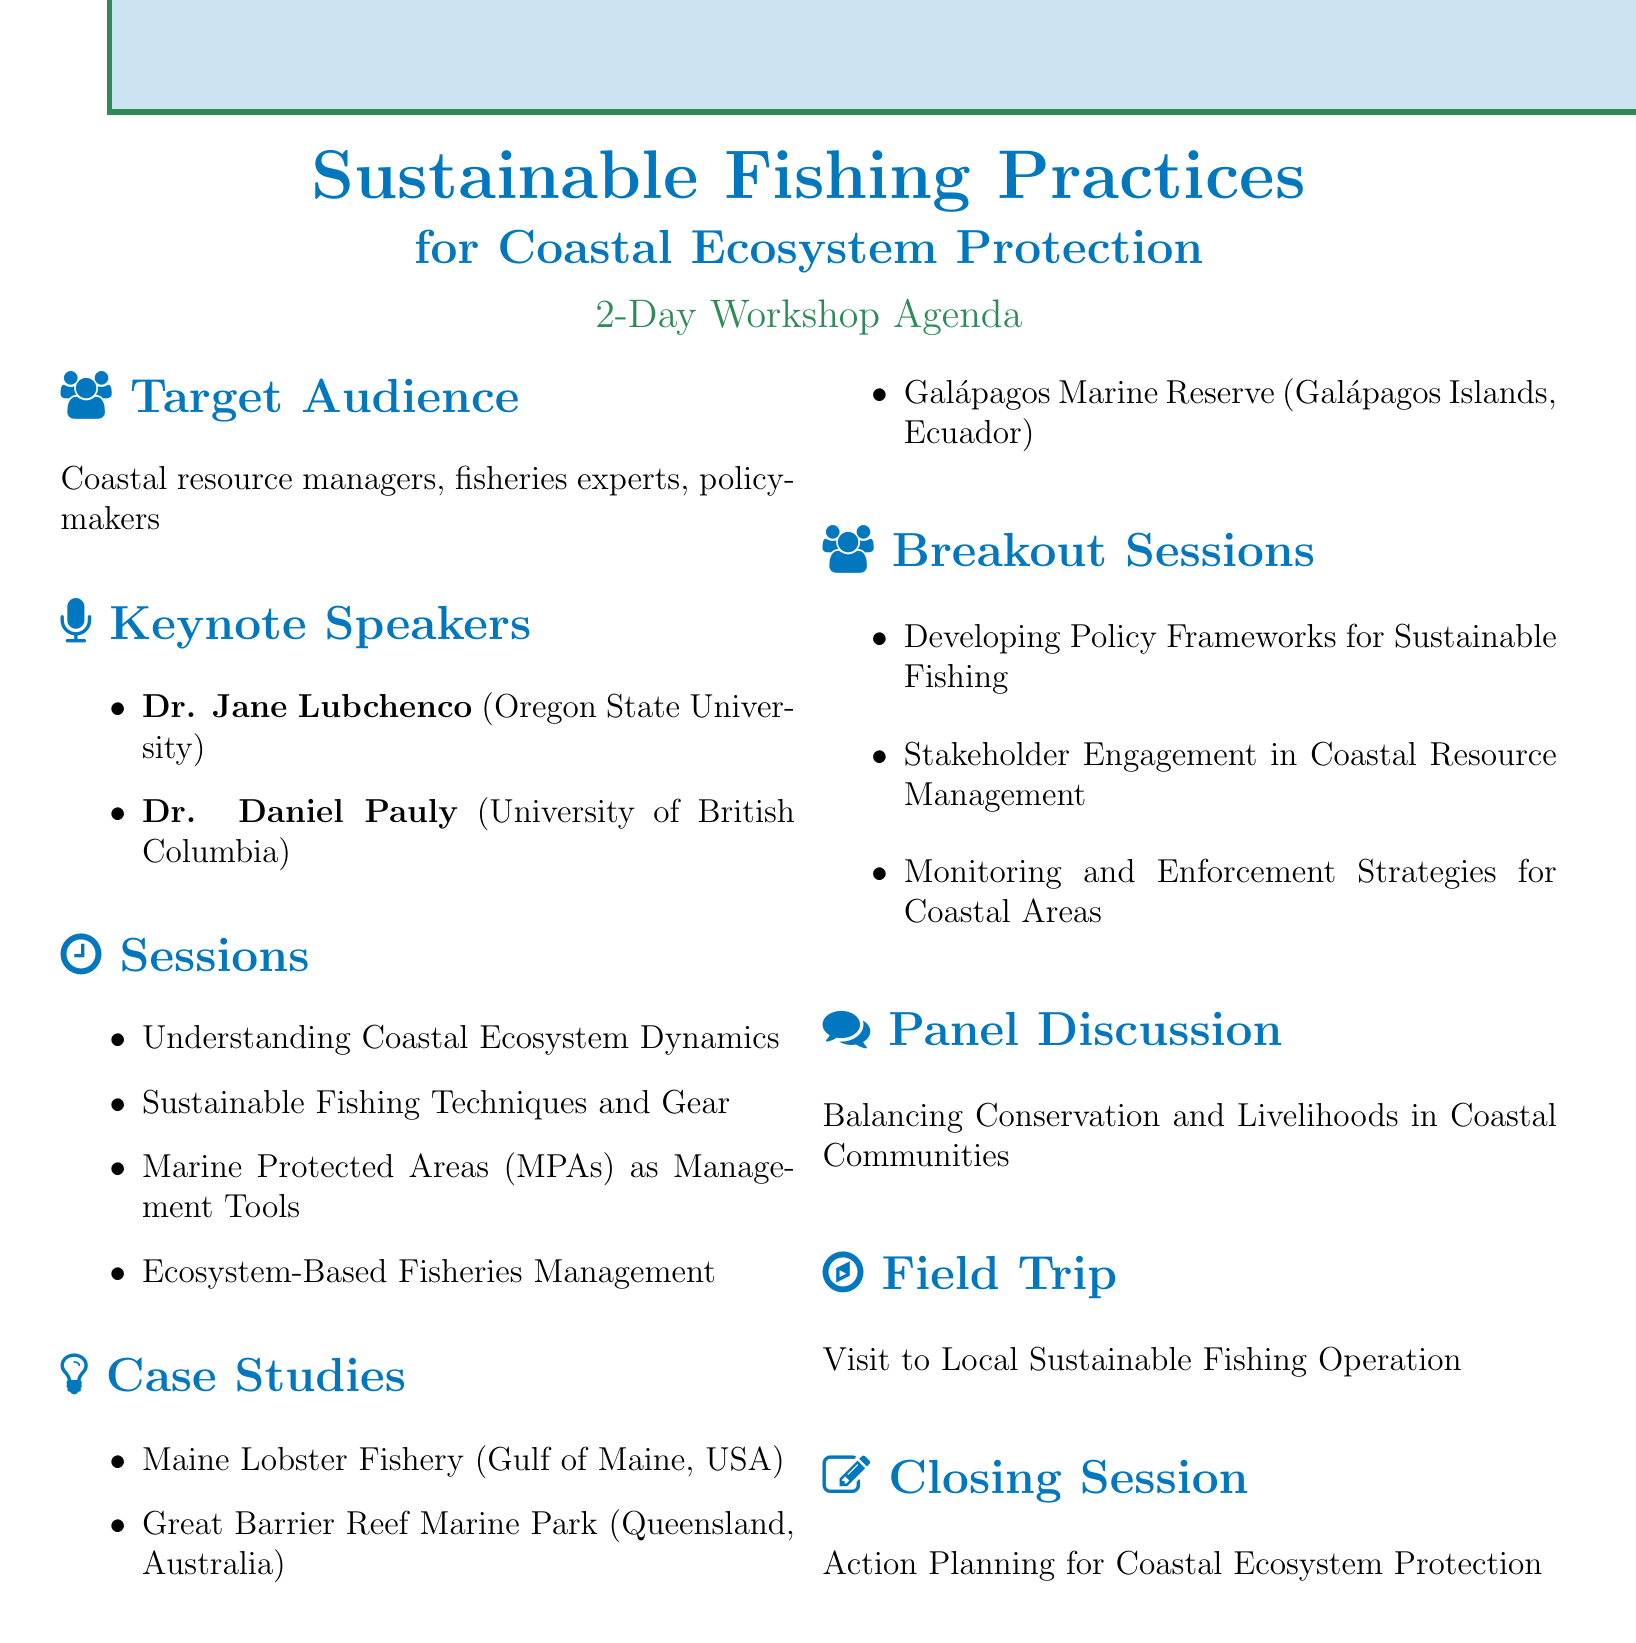what is the title of the workshop? The title of the workshop is the first line of the document.
Answer: Sustainable Fishing Practices for Coastal Ecosystem Protection who is the facilitator of the breakout session on stakeholder engagement? This information can be found in the breakout sessions section of the document.
Answer: Dr. Ratana Chuenpagdee how many case studies are presented in the workshop? The number of case studies can be counted in the case studies section.
Answer: 3 what is the main theme of the panel discussion? The main theme is mentioned in the panel discussion section of the document.
Answer: Balancing Conservation and Livelihoods in Coastal Communities who is presenting on ecosystem-based fisheries management? This information is provided in the sessions section, detailing presenters of each session.
Answer: Dr. Beth Fulton what is the location of the field trip? The field trip section states that the location is yet to be determined.
Answer: To be determined based on workshop venue how long is the workshop scheduled for? The duration of the workshop is explicitly stated in the document.
Answer: 2 days what type of audience is targeted for this workshop? The target audience is clearly listed at the start of the document.
Answer: Coastal resource managers, fisheries experts, policymakers 